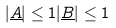Convert formula to latex. <formula><loc_0><loc_0><loc_500><loc_500>| \underline { A } | \leq 1 | \underline { B } | \leq 1</formula> 